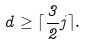Convert formula to latex. <formula><loc_0><loc_0><loc_500><loc_500>d \geq \lceil \frac { 3 } { 2 } j \rceil .</formula> 